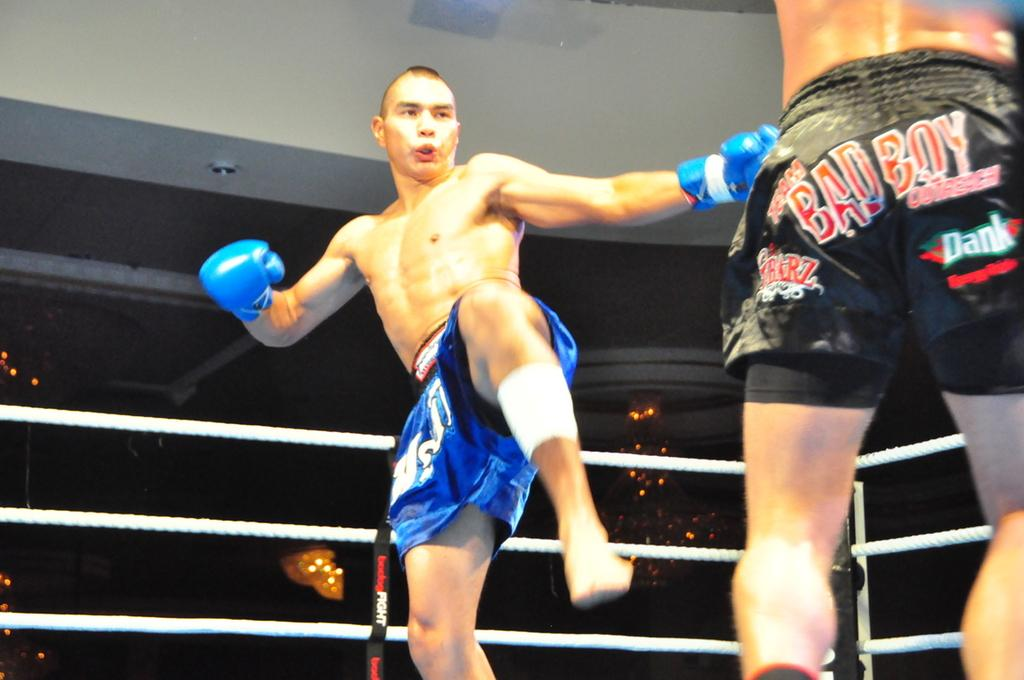<image>
Summarize the visual content of the image. kick boxer in blue going against guy in black trunks with bad boy written on the backside 